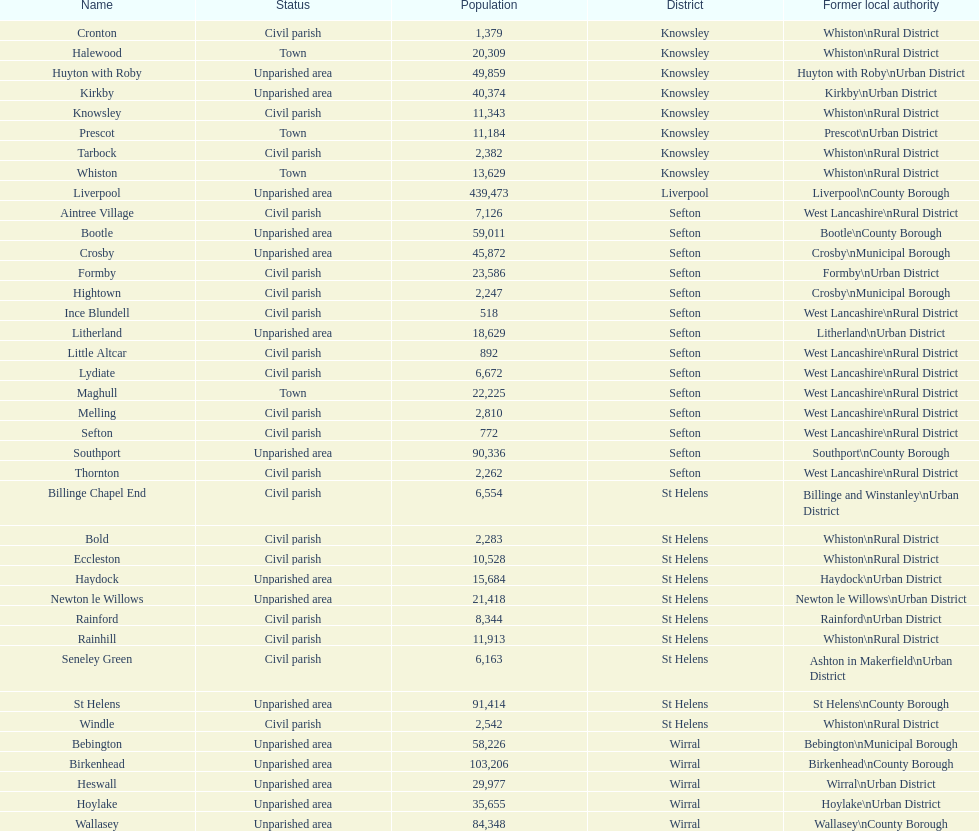Provide the quantity of people living in formby. 23,586. 